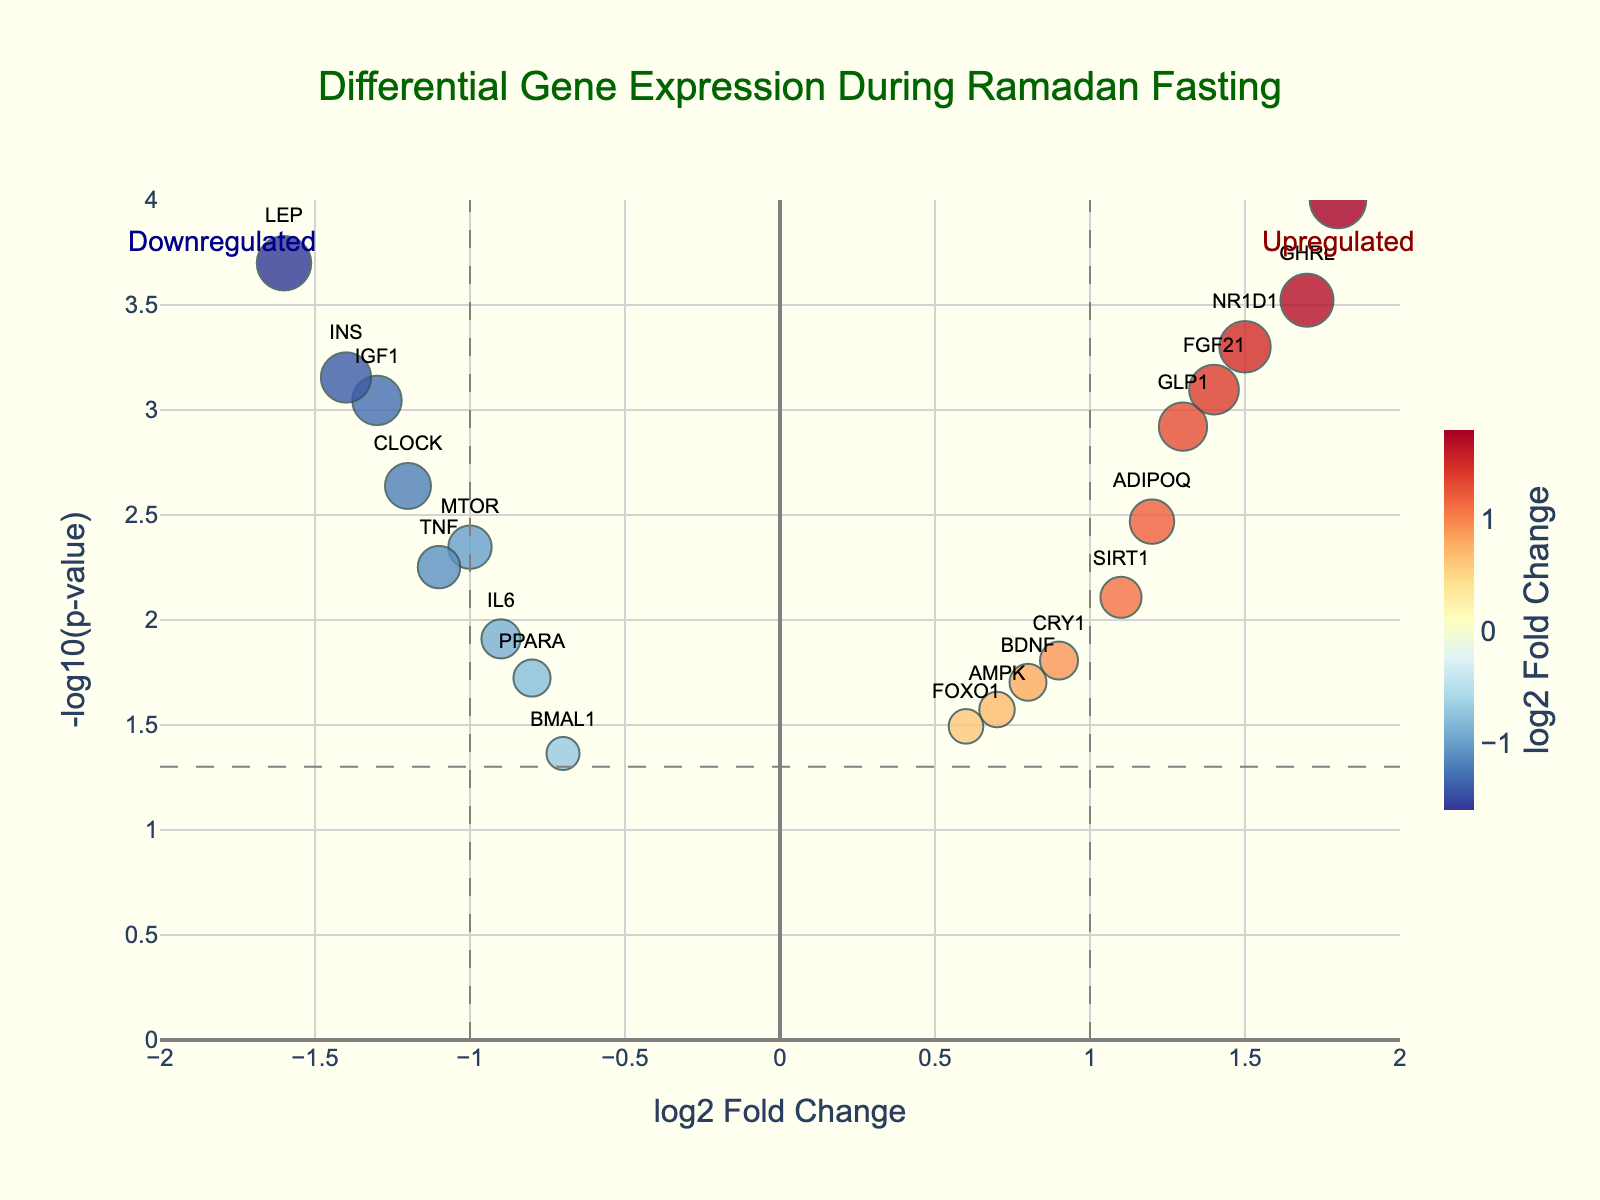What is the main title of the Volcano Plot? The main title of the figure is printed prominently at the top.
Answer: Differential Gene Expression During Ramadan Fasting Which gene has the highest -log10(p-value)? The most significant gene will be on the highest position on the y-axis of the plot. Here, it is PER2.
Answer: PER2 How many genes are upregulated with a log2FoldChange greater than 1 and a -log10(p-value) higher than 1.3? Start by identifying genes with log2FoldChange > 1, then count those with -log10(p-value) > 1.3. These are NR1D1, SIRT1, GHRL, FGF21, and PER2 - 5 genes in total.
Answer: 5 Which gene is downregulated the most during Ramadan fasting? This gene will have the most negative log2FoldChange value on the plot. Since LEP has the lowest log2FoldChange of -1.6, it is the most downregulated.
Answer: LEP What is the log2FoldChange and -log10(p-value) for the gene INS? Check the coordinates of the point labeled INS on the plot. INS has log2FoldChange = -1.4 and -log10(p-value) around 3.15.
Answer: log2FoldChange = -1.4, -log10(p-value) ≈ 3.15 Which gene has the lowest -log10(p-value) while still being considered downregulated? Among the genes with log2FoldChange < 0, locate the one with the smallest -log10(p-value) on the plot. BMAL1 has the smallest -log10(p-value) around 1.37.
Answer: BMAL1 What is the difference in the -log10(p-value) between the least and most significantly upregulated gene? The highest -log10(p-value) is for PER2 (~4) and the least significant is BMAL1 (~1.37), so the difference is 4 - 1.37 ≈ 2.63.
Answer: ~2.63 Is there a gene close to the threshold of being considered significantly upregulated but isn't? Which one is it? The significance threshold can be approximated as -log10(p-value) = 1.3 and log2FoldChange > 0. CRY1 is just below this threshold.
Answer: CRY1 